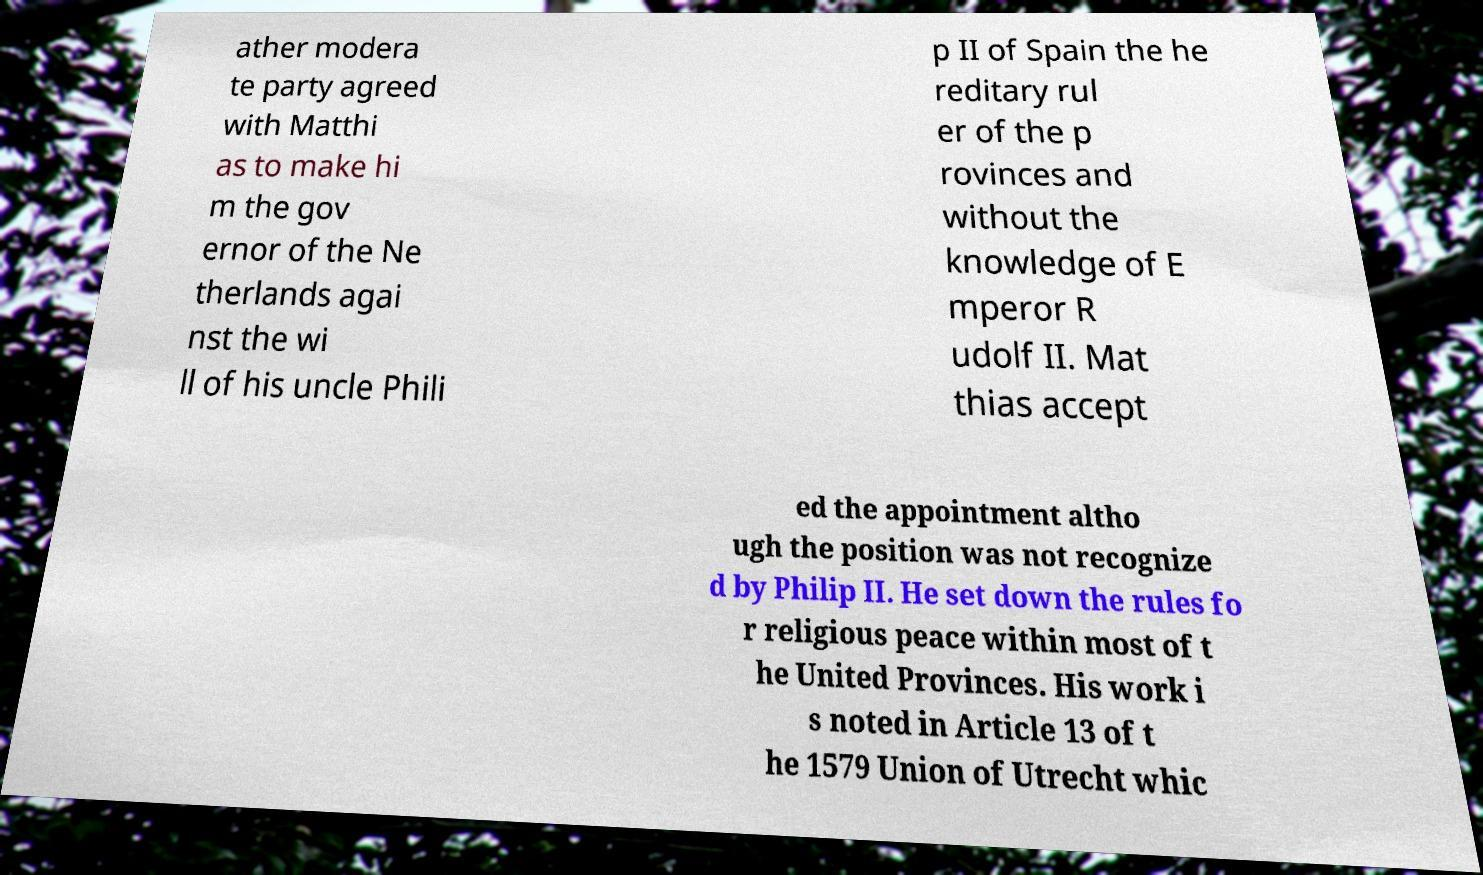Please read and relay the text visible in this image. What does it say? ather modera te party agreed with Matthi as to make hi m the gov ernor of the Ne therlands agai nst the wi ll of his uncle Phili p II of Spain the he reditary rul er of the p rovinces and without the knowledge of E mperor R udolf II. Mat thias accept ed the appointment altho ugh the position was not recognize d by Philip II. He set down the rules fo r religious peace within most of t he United Provinces. His work i s noted in Article 13 of t he 1579 Union of Utrecht whic 